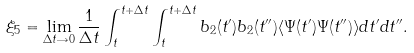Convert formula to latex. <formula><loc_0><loc_0><loc_500><loc_500>\xi _ { 5 } = \lim _ { \Delta t \rightarrow 0 } \frac { 1 } { \Delta t } \int _ { t } ^ { t + \Delta t } \int _ { t } ^ { t + \Delta t } b _ { 2 } ( t ^ { \prime } ) b _ { 2 } ( t ^ { \prime \prime } ) \langle \Psi ( t ^ { \prime } ) \Psi ( t ^ { \prime \prime } ) \rangle d t ^ { \prime } d t ^ { \prime \prime } .</formula> 